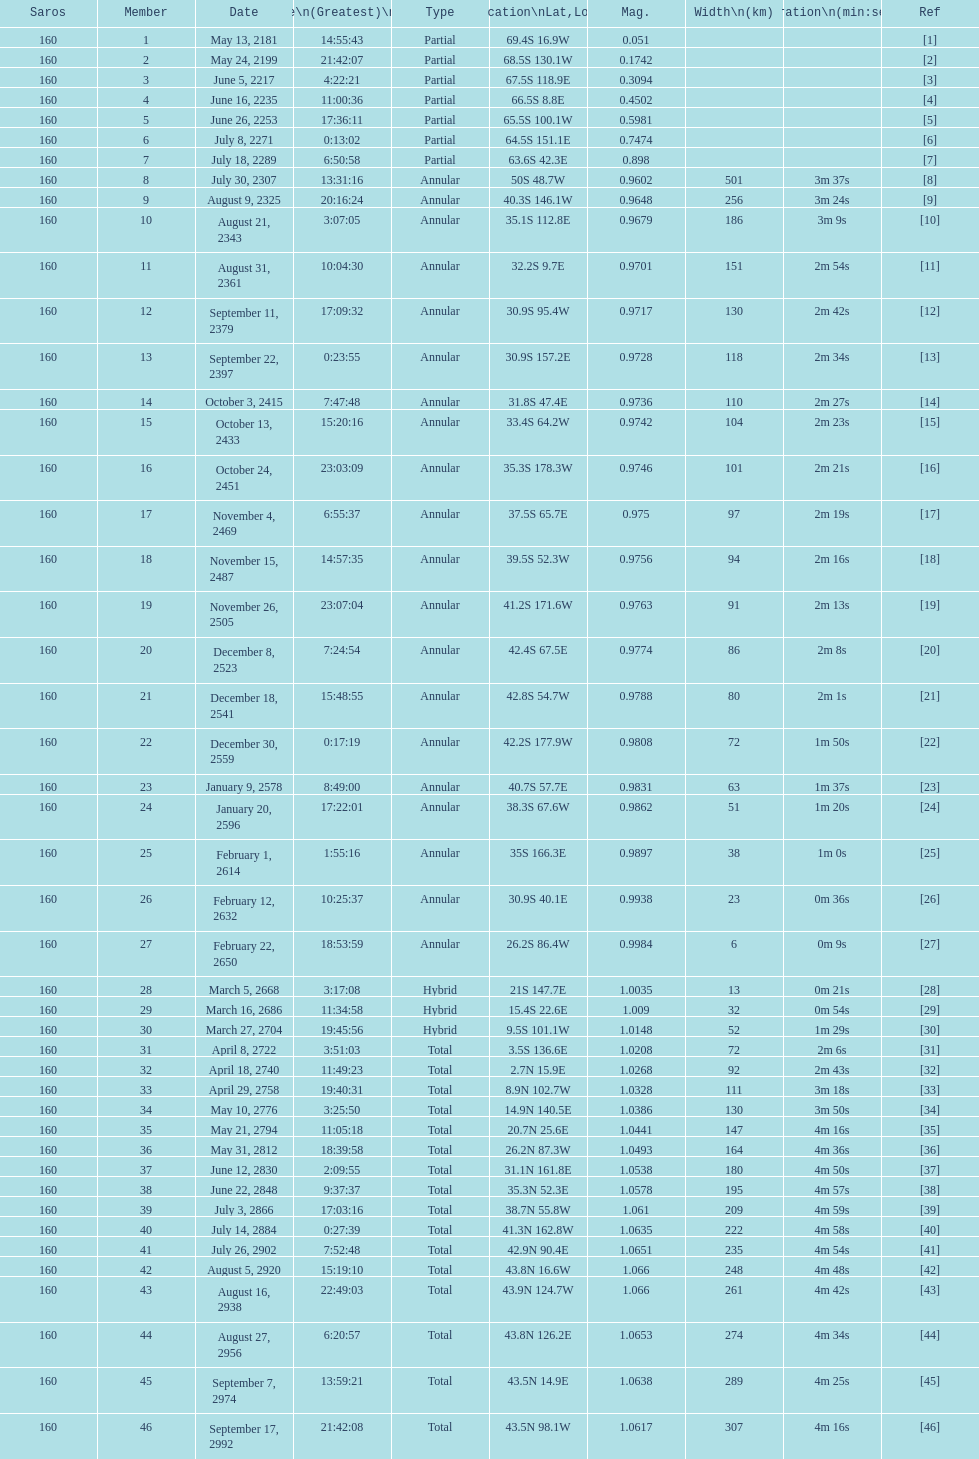Before the occurrence of the first annular, what is the number of partial members? 7. 